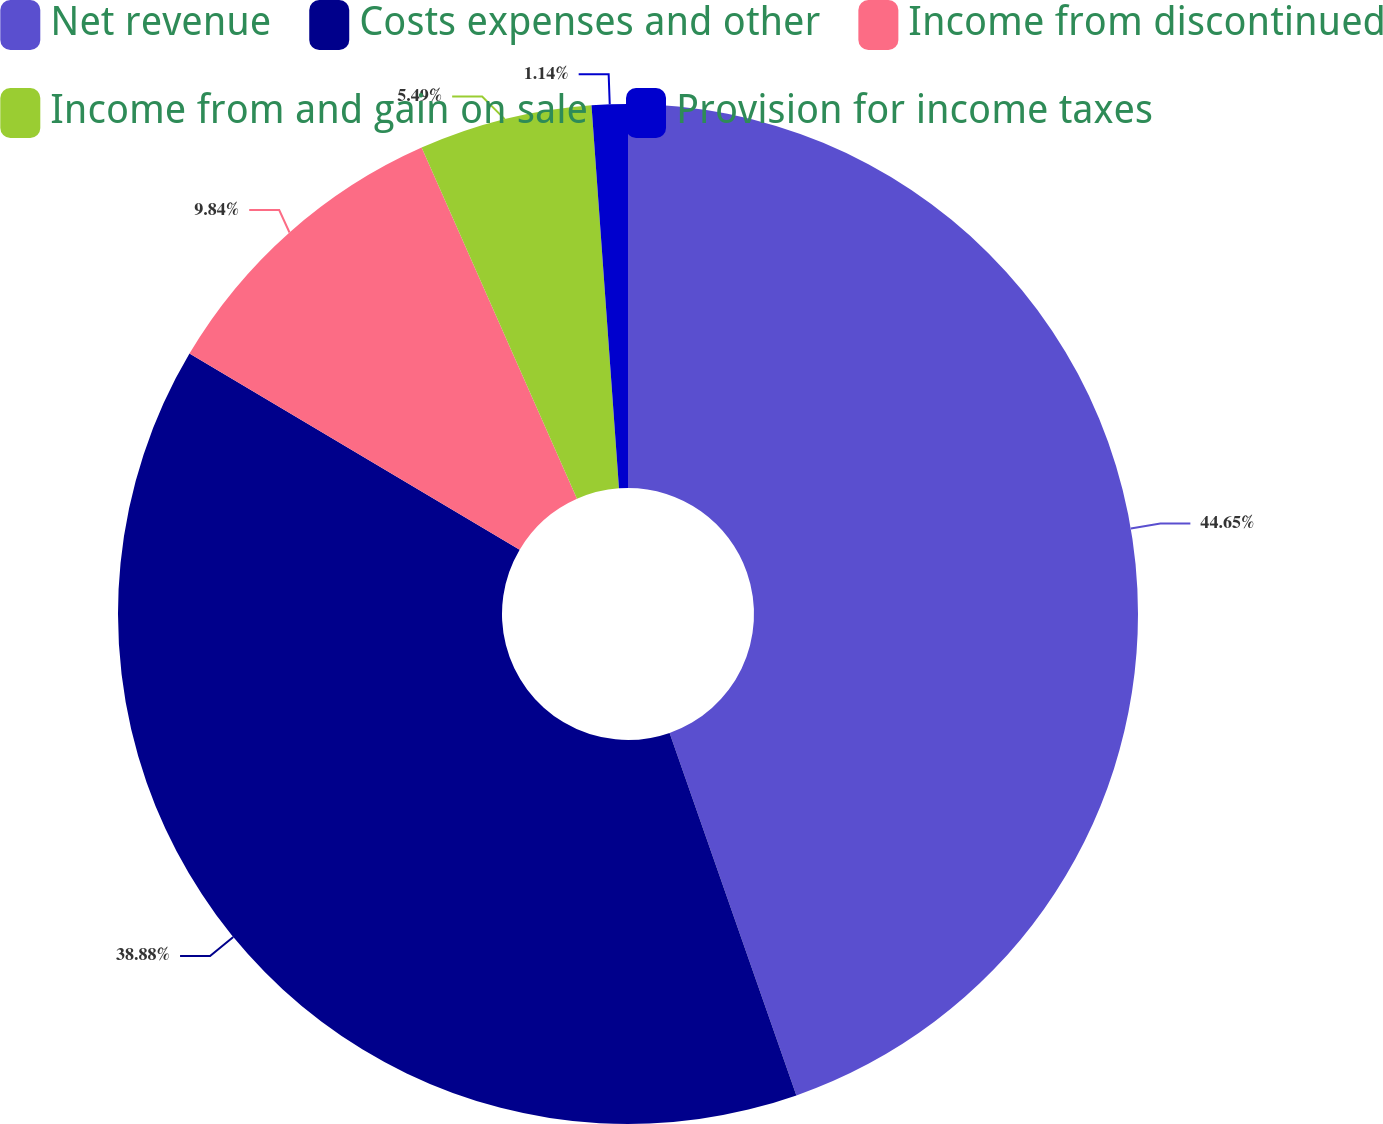Convert chart. <chart><loc_0><loc_0><loc_500><loc_500><pie_chart><fcel>Net revenue<fcel>Costs expenses and other<fcel>Income from discontinued<fcel>Income from and gain on sale<fcel>Provision for income taxes<nl><fcel>44.64%<fcel>38.88%<fcel>9.84%<fcel>5.49%<fcel>1.14%<nl></chart> 